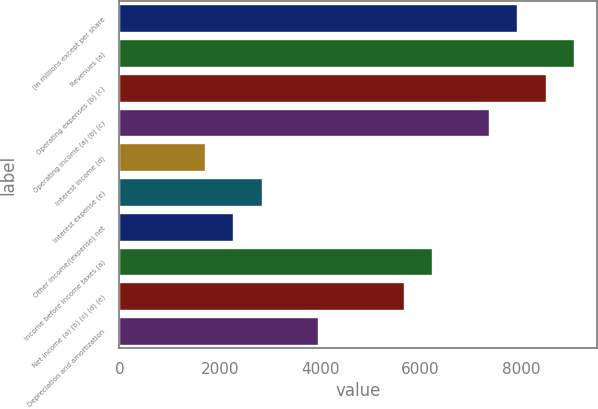Convert chart. <chart><loc_0><loc_0><loc_500><loc_500><bar_chart><fcel>(in millions except per share<fcel>Revenues (a)<fcel>Operating expenses (b) (c)<fcel>Operating income (a) (b) (c)<fcel>Interest income (d)<fcel>Interest expense (e)<fcel>Other income/(expense) net<fcel>Income before income taxes (a)<fcel>Net income (a) (b) (c) (d) (e)<fcel>Depreciation and amortization<nl><fcel>7930.58<fcel>9063.46<fcel>8497.02<fcel>7364.14<fcel>1699.74<fcel>2832.62<fcel>2266.18<fcel>6231.26<fcel>5664.82<fcel>3965.5<nl></chart> 